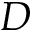Convert formula to latex. <formula><loc_0><loc_0><loc_500><loc_500>D</formula> 